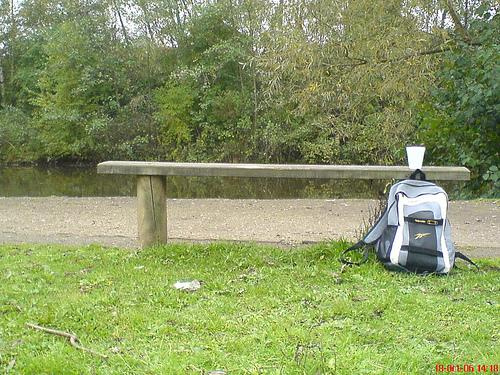Provide a brief overview of the scene in the image. The image features a park scene with a wooden bench near a pond, surrounded by trees and shrubbery, a backpack and a cup resting on the bench, and a stick and litter on the grass. Describe the main object and its surrounding in the picture. A wooden park bench sits next to a pond, framed by green trees and bushes, with a blue and white backpack leaning against it, and a white cup on top. List the notable elements in the image along with their details. - Grass: bright green and brown, stick and litter present Summarize the image in one sentence by highlighting the main elements. A scenic park features a wooden bench by a pond, a blue and white backpack resting against it, a white cup placed on it, and some stick and litter in the grass. Give a poetic description of the scene displayed in the image. Amidst vibrant greens and still waters, a lakeside bench whispers stories untold, while a backpack rests, and a cup awaits the hand that left it behind. Narrate the image as if observed by someone who is at the park. As I stroll through the park, I notice a serene pond hugged by a wooden bench that's keeping a backpack and cup company, while the trees whisper and litter play hide-and-seek in the grass. Describe the location and items found in the image using passive voice. A park bench, made of wood and cement, is situated by a pond, surrounded by trees and bushes. A blue and white backpack is seen resting against it, and a white cup is placed upon it. Mention the primary focal points of the image and their characteristics. Key focus points include a wooden bench near a pond in a tree-covered park, a blue and white backpack against the bench, and a white cup on the bench, along with a stick and litter on the grass. Describe the image incorporating an alliteration. Beside a babbling brook, beneath the boughs of verdant trees, a bench beckons one to pause and admire, as a backpack and a cup keep watch amongst the swaying grasses. In simple words, tell what you see in the image. A bench is by a pond in a park with trees. A backpack is leaning on the bench, and there's a cup on the bench. There's a stick and litter on the grass. 